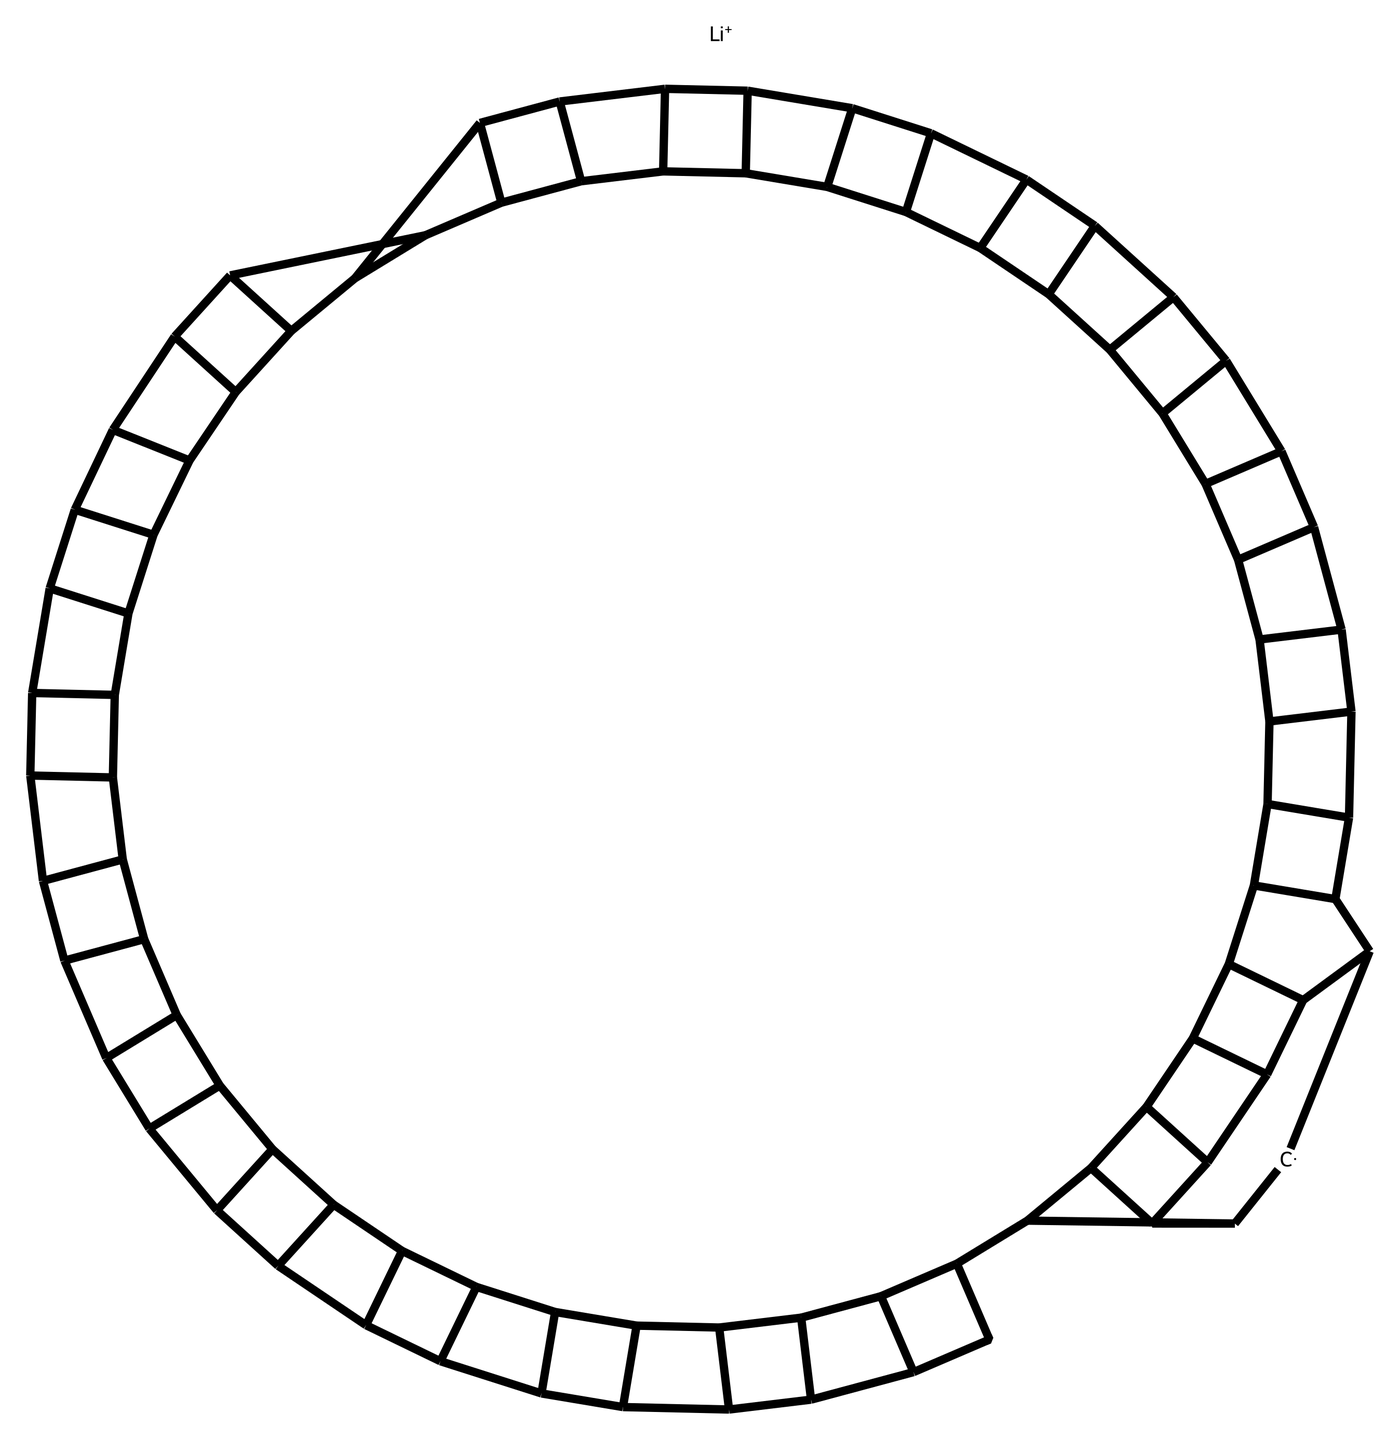What is the cation in this chemical? The chemical structure contains a lithium ion denoted as [Li+]. This indicates that lithium is present, and it exists in a positively charged state as a cation.
Answer: lithium How many carbon atoms are in the structure? By analyzing the SMILES representation, the carbon atoms can be counted based on the presence of 'C' symbols. There are numerous C atoms present in the complex fullerene structure represented here, totaling 60 carbon atoms when fully realized.
Answer: 60 What type of bonding is primarily present in lithium fulleride? Lithium fulleride primarily exhibits ionic bonding due to the presence of the lithium cation ([Li+]) interacting with the electron-rich fulleride anions (C60). Ionic bonds involve the electrostatic attraction between positively and negatively charged ions.
Answer: ionic What is the main structural component of fullerides? The main structural component of fullerides is a network of carbon atoms arranged in a spherical shape. This arrangement is characteristic of the fullerene family, where carbon forms a hollow cage-like structure.
Answer: carbon network Why might lithium fulleride be important in explosive residue detection? Lithium fulleride can exhibit unique electronic properties, making it sensitive to various chemical interactions. This sensitivity can facilitate its use in detecting certain residues associated with explosives, enhancing identification methods in criminology.
Answer: unique electronic properties What is a unique property of fullerides compared to other carbon allotropes? Fullerides, specifically the structure of fullerene, are known for their hollow shape and potential to form stable complexes with ions like lithium, which is not typical in other allotropes such as graphite or diamond.
Answer: hollow shape 